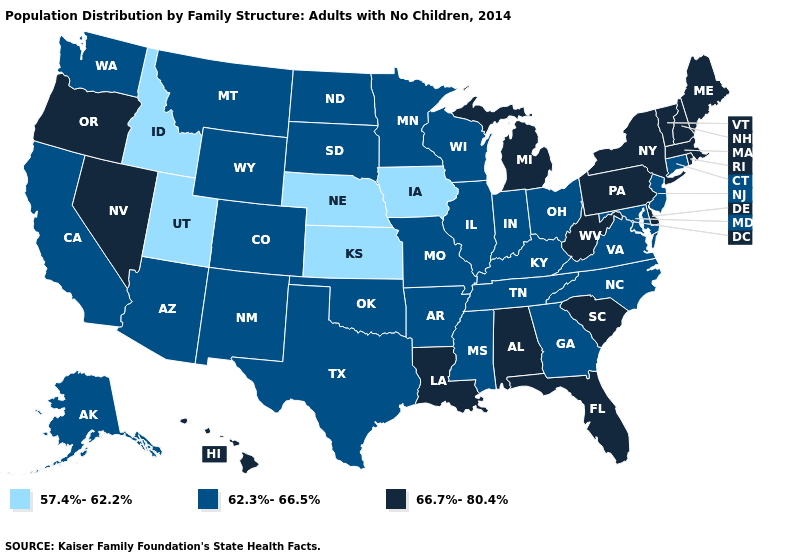Does Wyoming have the highest value in the USA?
Answer briefly. No. Among the states that border Ohio , does Michigan have the highest value?
Quick response, please. Yes. Name the states that have a value in the range 66.7%-80.4%?
Keep it brief. Alabama, Delaware, Florida, Hawaii, Louisiana, Maine, Massachusetts, Michigan, Nevada, New Hampshire, New York, Oregon, Pennsylvania, Rhode Island, South Carolina, Vermont, West Virginia. Name the states that have a value in the range 66.7%-80.4%?
Be succinct. Alabama, Delaware, Florida, Hawaii, Louisiana, Maine, Massachusetts, Michigan, Nevada, New Hampshire, New York, Oregon, Pennsylvania, Rhode Island, South Carolina, Vermont, West Virginia. What is the highest value in the MidWest ?
Keep it brief. 66.7%-80.4%. What is the lowest value in states that border Nebraska?
Short answer required. 57.4%-62.2%. What is the value of Washington?
Quick response, please. 62.3%-66.5%. What is the value of Virginia?
Write a very short answer. 62.3%-66.5%. Name the states that have a value in the range 66.7%-80.4%?
Keep it brief. Alabama, Delaware, Florida, Hawaii, Louisiana, Maine, Massachusetts, Michigan, Nevada, New Hampshire, New York, Oregon, Pennsylvania, Rhode Island, South Carolina, Vermont, West Virginia. Does Wisconsin have the lowest value in the MidWest?
Answer briefly. No. Name the states that have a value in the range 57.4%-62.2%?
Be succinct. Idaho, Iowa, Kansas, Nebraska, Utah. Does Missouri have a higher value than Idaho?
Answer briefly. Yes. Name the states that have a value in the range 66.7%-80.4%?
Be succinct. Alabama, Delaware, Florida, Hawaii, Louisiana, Maine, Massachusetts, Michigan, Nevada, New Hampshire, New York, Oregon, Pennsylvania, Rhode Island, South Carolina, Vermont, West Virginia. What is the value of Rhode Island?
Give a very brief answer. 66.7%-80.4%. Which states have the lowest value in the MidWest?
Keep it brief. Iowa, Kansas, Nebraska. 